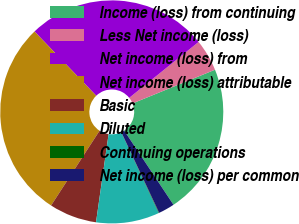Convert chart. <chart><loc_0><loc_0><loc_500><loc_500><pie_chart><fcel>Income (loss) from continuing<fcel>Less Net income (loss)<fcel>Net income (loss) from<fcel>Net income (loss) attributable<fcel>Basic<fcel>Diluted<fcel>Continuing operations<fcel>Net income (loss) per common<nl><fcel>21.84%<fcel>4.62%<fcel>26.39%<fcel>28.66%<fcel>6.9%<fcel>9.17%<fcel>0.07%<fcel>2.35%<nl></chart> 